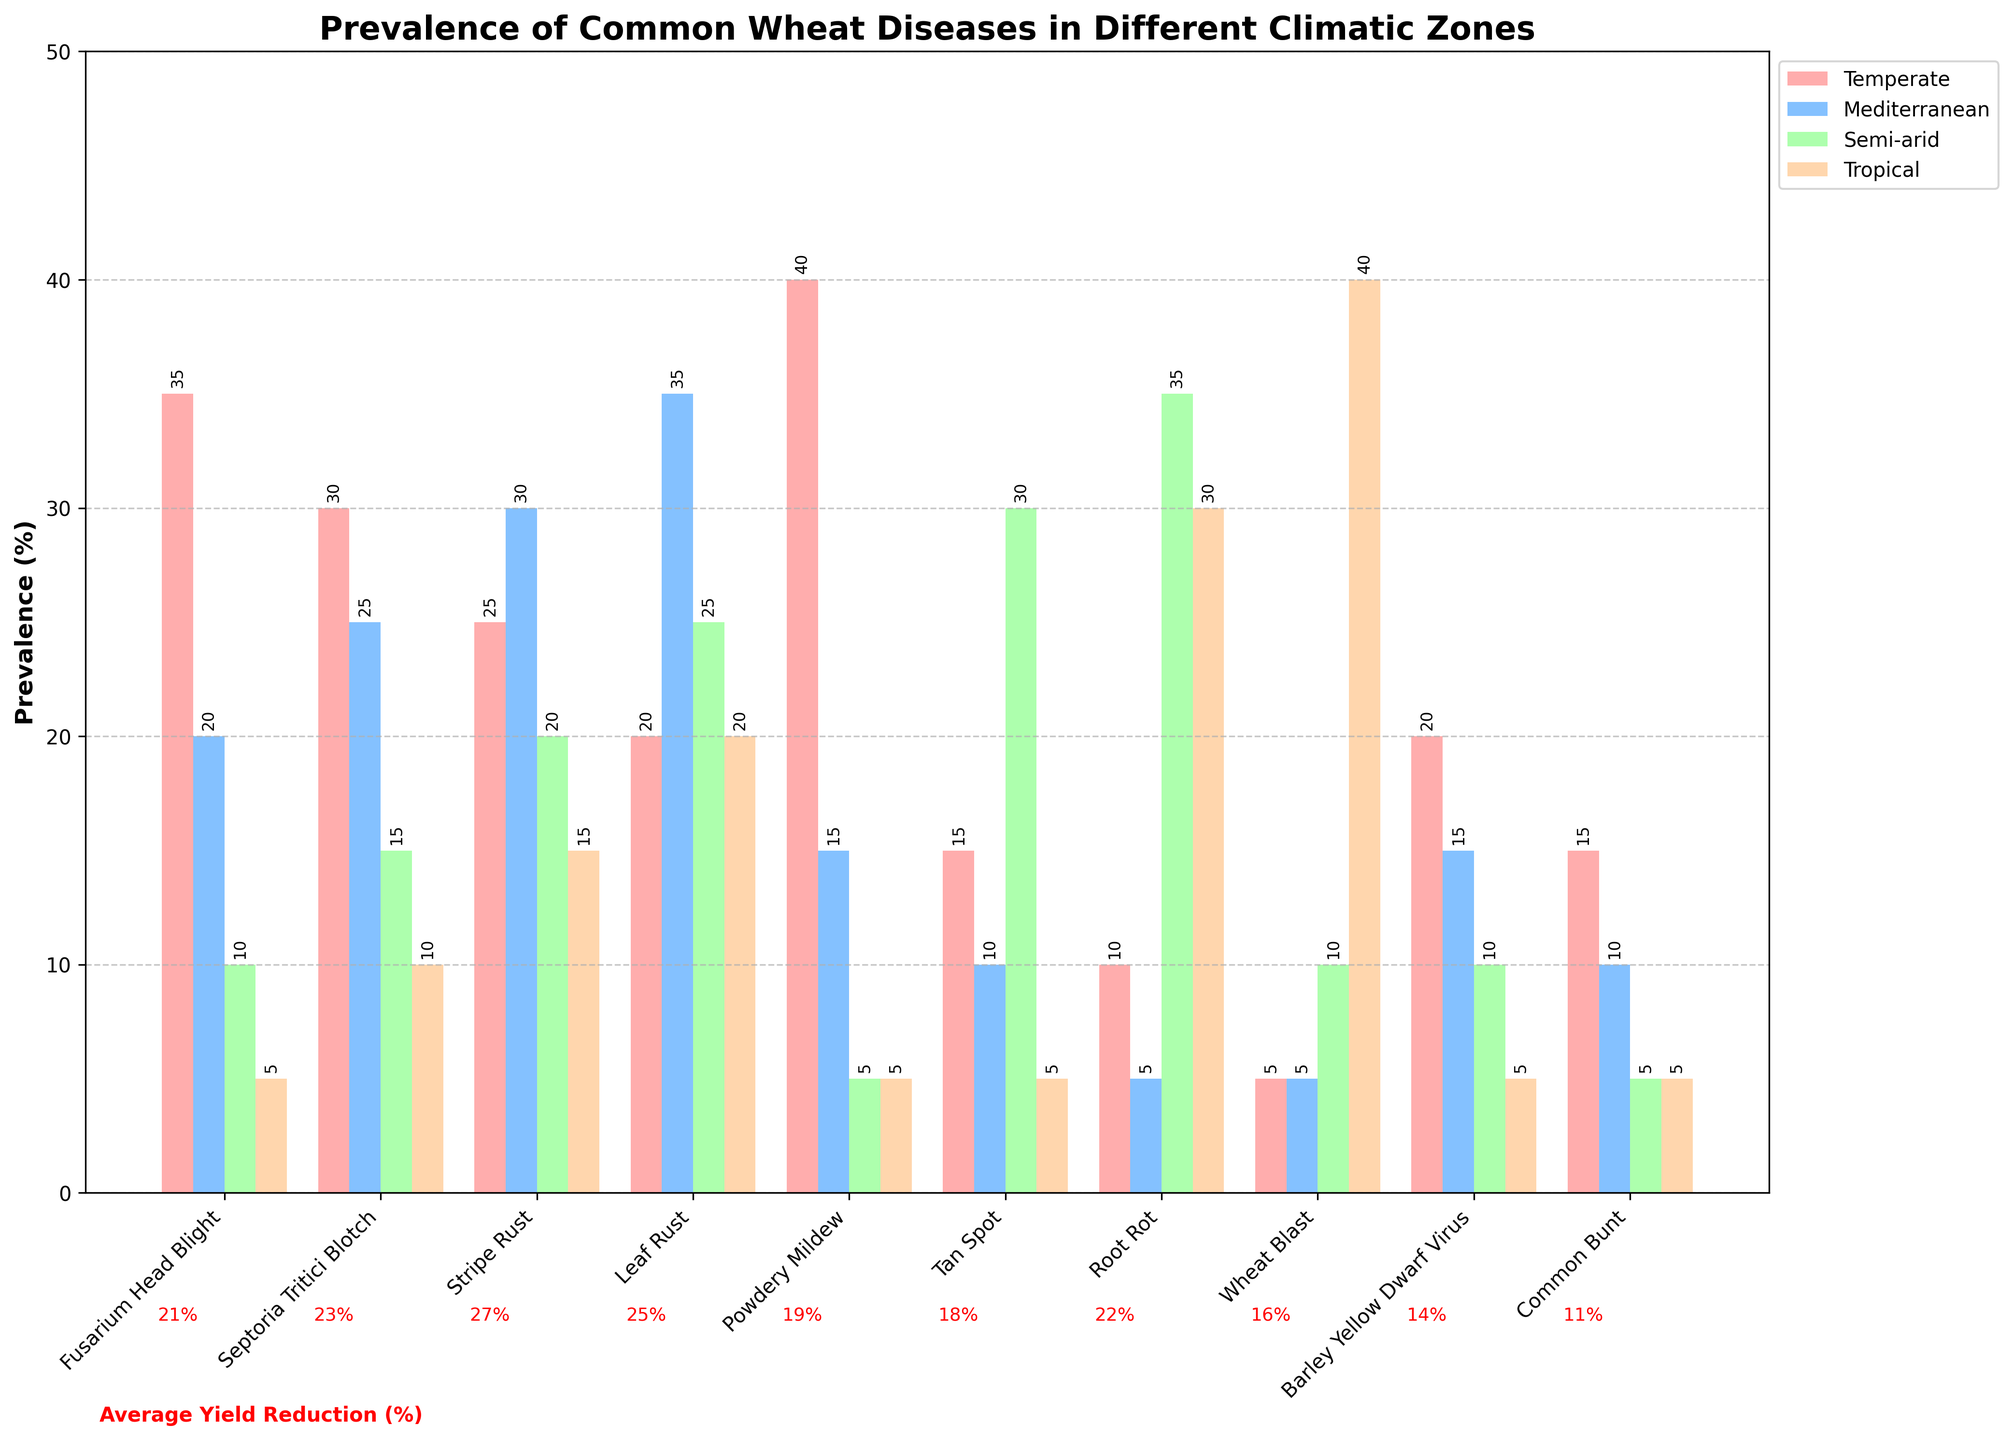What is the average prevalence of Fusarium Head Blight across all climatic zones? To calculate the average prevalence, add the prevalence percentages from all climatic zones (35 + 20 + 10 + 5) and divide by the number of climatic zones (4). (35 + 20 + 10 + 5) / 4 = 17.5
Answer: 17.5% In which climatic zone is Septoria Tritici Blotch most prevalent? Identify the highest bar for Septoria Tritici Blotch among the four climatic zones: Temperate (30%), Mediterranean (25%), Semi-arid (15%), and Tropical (10%). The highest value is 30%, found in the Temperate zone.
Answer: Temperate What is the total prevalence of diseases in the Tropical zone? Sum the prevalence percentages of all diseases in the Tropical climatic zone: 
- Fusarium Head Blight: 5%
- Septoria Tritici Blotch: 10%
- Stripe Rust: 15%
- Leaf Rust: 20%
- Powdery Mildew: 5%
- Tan Spot: 5%
- Root Rot: 30%
- Wheat Blast: 40%
- Barley Yellow Dwarf Virus: 5%
- Common Bunt: 5% 
The total is 5 + 10 + 15 + 20 + 5 + 5 + 30 + 40 + 5 + 5 = 140
Answer: 140% Which disease is uniformly prevalent across all climatic zones? Look for a disease with equal prevalence in all four zones. Fusarium Head Blight, Powdery Mildew, Tan Spot, Root Rot, Wheat Blast, Barley Yellow Dwarf Virus, and Common Bunt display variable prevalences, but none is uniformly prevalent across all zones.
Answer: None 